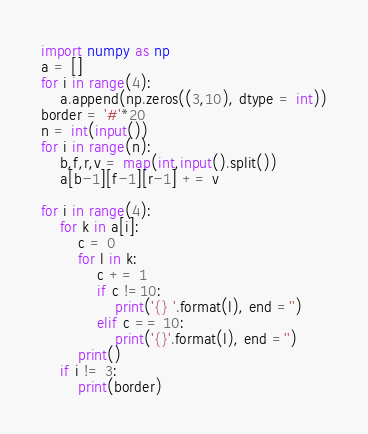Convert code to text. <code><loc_0><loc_0><loc_500><loc_500><_Python_>import numpy as np
a = []
for i in range(4):
    a.append(np.zeros((3,10), dtype = int))
border = '#'*20
n = int(input())
for i in range(n):
    b,f,r,v = map(int,input().split())
    a[b-1][f-1][r-1] += v
    
for i in range(4):
    for k in a[i]:
        c = 0
        for l in k:
            c += 1
            if c !=10:
                print('{} '.format(l), end ='')
            elif c == 10:
                print('{}'.format(l), end ='')
        print()
    if i != 3:
        print(border)
</code> 